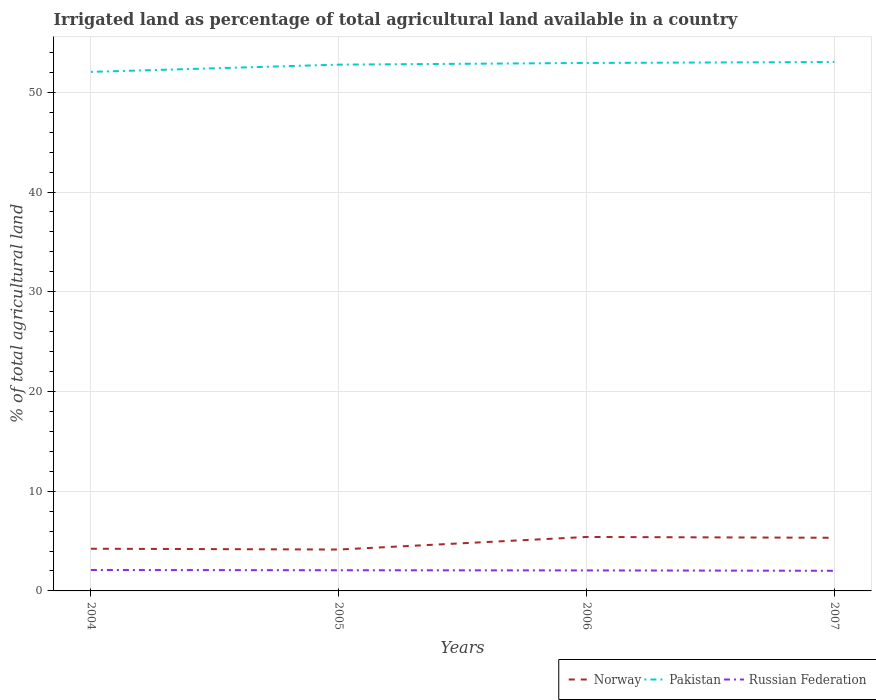How many different coloured lines are there?
Offer a terse response. 3. Is the number of lines equal to the number of legend labels?
Provide a succinct answer. Yes. Across all years, what is the maximum percentage of irrigated land in Norway?
Provide a succinct answer. 4.15. In which year was the percentage of irrigated land in Norway maximum?
Offer a terse response. 2005. What is the total percentage of irrigated land in Norway in the graph?
Give a very brief answer. 0.08. What is the difference between the highest and the second highest percentage of irrigated land in Norway?
Ensure brevity in your answer.  1.26. What is the difference between the highest and the lowest percentage of irrigated land in Pakistan?
Give a very brief answer. 3. Is the percentage of irrigated land in Pakistan strictly greater than the percentage of irrigated land in Norway over the years?
Your answer should be very brief. No. How many lines are there?
Your answer should be very brief. 3. How many years are there in the graph?
Provide a short and direct response. 4. How many legend labels are there?
Give a very brief answer. 3. What is the title of the graph?
Make the answer very short. Irrigated land as percentage of total agricultural land available in a country. What is the label or title of the X-axis?
Your answer should be compact. Years. What is the label or title of the Y-axis?
Offer a terse response. % of total agricultural land. What is the % of total agricultural land of Norway in 2004?
Provide a short and direct response. 4.23. What is the % of total agricultural land in Pakistan in 2004?
Keep it short and to the point. 52.05. What is the % of total agricultural land of Russian Federation in 2004?
Your answer should be very brief. 2.1. What is the % of total agricultural land of Norway in 2005?
Provide a short and direct response. 4.15. What is the % of total agricultural land of Pakistan in 2005?
Give a very brief answer. 52.77. What is the % of total agricultural land of Russian Federation in 2005?
Give a very brief answer. 2.07. What is the % of total agricultural land of Norway in 2006?
Provide a short and direct response. 5.41. What is the % of total agricultural land in Pakistan in 2006?
Your answer should be very brief. 52.94. What is the % of total agricultural land in Russian Federation in 2006?
Offer a terse response. 2.06. What is the % of total agricultural land of Norway in 2007?
Make the answer very short. 5.33. What is the % of total agricultural land of Pakistan in 2007?
Offer a terse response. 53.04. What is the % of total agricultural land of Russian Federation in 2007?
Keep it short and to the point. 2.02. Across all years, what is the maximum % of total agricultural land of Norway?
Make the answer very short. 5.41. Across all years, what is the maximum % of total agricultural land in Pakistan?
Give a very brief answer. 53.04. Across all years, what is the maximum % of total agricultural land in Russian Federation?
Provide a succinct answer. 2.1. Across all years, what is the minimum % of total agricultural land in Norway?
Make the answer very short. 4.15. Across all years, what is the minimum % of total agricultural land in Pakistan?
Offer a terse response. 52.05. Across all years, what is the minimum % of total agricultural land in Russian Federation?
Make the answer very short. 2.02. What is the total % of total agricultural land of Norway in the graph?
Offer a very short reply. 19.12. What is the total % of total agricultural land of Pakistan in the graph?
Keep it short and to the point. 210.8. What is the total % of total agricultural land in Russian Federation in the graph?
Give a very brief answer. 8.25. What is the difference between the % of total agricultural land of Norway in 2004 and that in 2005?
Offer a terse response. 0.08. What is the difference between the % of total agricultural land of Pakistan in 2004 and that in 2005?
Your response must be concise. -0.73. What is the difference between the % of total agricultural land in Russian Federation in 2004 and that in 2005?
Keep it short and to the point. 0.02. What is the difference between the % of total agricultural land in Norway in 2004 and that in 2006?
Ensure brevity in your answer.  -1.18. What is the difference between the % of total agricultural land of Pakistan in 2004 and that in 2006?
Offer a terse response. -0.89. What is the difference between the % of total agricultural land of Russian Federation in 2004 and that in 2006?
Provide a short and direct response. 0.04. What is the difference between the % of total agricultural land in Norway in 2004 and that in 2007?
Give a very brief answer. -1.1. What is the difference between the % of total agricultural land of Pakistan in 2004 and that in 2007?
Keep it short and to the point. -0.99. What is the difference between the % of total agricultural land in Russian Federation in 2004 and that in 2007?
Offer a very short reply. 0.08. What is the difference between the % of total agricultural land of Norway in 2005 and that in 2006?
Make the answer very short. -1.26. What is the difference between the % of total agricultural land in Pakistan in 2005 and that in 2006?
Keep it short and to the point. -0.17. What is the difference between the % of total agricultural land in Russian Federation in 2005 and that in 2006?
Give a very brief answer. 0.02. What is the difference between the % of total agricultural land of Norway in 2005 and that in 2007?
Ensure brevity in your answer.  -1.18. What is the difference between the % of total agricultural land of Pakistan in 2005 and that in 2007?
Offer a very short reply. -0.26. What is the difference between the % of total agricultural land in Russian Federation in 2005 and that in 2007?
Give a very brief answer. 0.06. What is the difference between the % of total agricultural land in Norway in 2006 and that in 2007?
Your answer should be very brief. 0.08. What is the difference between the % of total agricultural land of Pakistan in 2006 and that in 2007?
Provide a short and direct response. -0.1. What is the difference between the % of total agricultural land in Russian Federation in 2006 and that in 2007?
Keep it short and to the point. 0.04. What is the difference between the % of total agricultural land of Norway in 2004 and the % of total agricultural land of Pakistan in 2005?
Your response must be concise. -48.54. What is the difference between the % of total agricultural land in Norway in 2004 and the % of total agricultural land in Russian Federation in 2005?
Offer a terse response. 2.16. What is the difference between the % of total agricultural land in Pakistan in 2004 and the % of total agricultural land in Russian Federation in 2005?
Offer a terse response. 49.97. What is the difference between the % of total agricultural land of Norway in 2004 and the % of total agricultural land of Pakistan in 2006?
Provide a succinct answer. -48.71. What is the difference between the % of total agricultural land of Norway in 2004 and the % of total agricultural land of Russian Federation in 2006?
Offer a very short reply. 2.17. What is the difference between the % of total agricultural land of Pakistan in 2004 and the % of total agricultural land of Russian Federation in 2006?
Keep it short and to the point. 49.99. What is the difference between the % of total agricultural land of Norway in 2004 and the % of total agricultural land of Pakistan in 2007?
Offer a very short reply. -48.81. What is the difference between the % of total agricultural land of Norway in 2004 and the % of total agricultural land of Russian Federation in 2007?
Your answer should be compact. 2.21. What is the difference between the % of total agricultural land in Pakistan in 2004 and the % of total agricultural land in Russian Federation in 2007?
Offer a very short reply. 50.03. What is the difference between the % of total agricultural land in Norway in 2005 and the % of total agricultural land in Pakistan in 2006?
Provide a succinct answer. -48.79. What is the difference between the % of total agricultural land in Norway in 2005 and the % of total agricultural land in Russian Federation in 2006?
Offer a very short reply. 2.09. What is the difference between the % of total agricultural land of Pakistan in 2005 and the % of total agricultural land of Russian Federation in 2006?
Provide a short and direct response. 50.72. What is the difference between the % of total agricultural land of Norway in 2005 and the % of total agricultural land of Pakistan in 2007?
Ensure brevity in your answer.  -48.89. What is the difference between the % of total agricultural land in Norway in 2005 and the % of total agricultural land in Russian Federation in 2007?
Make the answer very short. 2.13. What is the difference between the % of total agricultural land of Pakistan in 2005 and the % of total agricultural land of Russian Federation in 2007?
Offer a very short reply. 50.75. What is the difference between the % of total agricultural land of Norway in 2006 and the % of total agricultural land of Pakistan in 2007?
Provide a succinct answer. -47.63. What is the difference between the % of total agricultural land in Norway in 2006 and the % of total agricultural land in Russian Federation in 2007?
Offer a very short reply. 3.39. What is the difference between the % of total agricultural land of Pakistan in 2006 and the % of total agricultural land of Russian Federation in 2007?
Your response must be concise. 50.92. What is the average % of total agricultural land of Norway per year?
Give a very brief answer. 4.78. What is the average % of total agricultural land in Pakistan per year?
Your response must be concise. 52.7. What is the average % of total agricultural land of Russian Federation per year?
Offer a very short reply. 2.06. In the year 2004, what is the difference between the % of total agricultural land in Norway and % of total agricultural land in Pakistan?
Provide a succinct answer. -47.82. In the year 2004, what is the difference between the % of total agricultural land in Norway and % of total agricultural land in Russian Federation?
Your answer should be very brief. 2.13. In the year 2004, what is the difference between the % of total agricultural land of Pakistan and % of total agricultural land of Russian Federation?
Keep it short and to the point. 49.95. In the year 2005, what is the difference between the % of total agricultural land in Norway and % of total agricultural land in Pakistan?
Provide a short and direct response. -48.62. In the year 2005, what is the difference between the % of total agricultural land in Norway and % of total agricultural land in Russian Federation?
Your answer should be compact. 2.08. In the year 2005, what is the difference between the % of total agricultural land of Pakistan and % of total agricultural land of Russian Federation?
Provide a succinct answer. 50.7. In the year 2006, what is the difference between the % of total agricultural land in Norway and % of total agricultural land in Pakistan?
Give a very brief answer. -47.53. In the year 2006, what is the difference between the % of total agricultural land of Norway and % of total agricultural land of Russian Federation?
Keep it short and to the point. 3.35. In the year 2006, what is the difference between the % of total agricultural land in Pakistan and % of total agricultural land in Russian Federation?
Make the answer very short. 50.88. In the year 2007, what is the difference between the % of total agricultural land in Norway and % of total agricultural land in Pakistan?
Provide a succinct answer. -47.71. In the year 2007, what is the difference between the % of total agricultural land in Norway and % of total agricultural land in Russian Federation?
Keep it short and to the point. 3.31. In the year 2007, what is the difference between the % of total agricultural land in Pakistan and % of total agricultural land in Russian Federation?
Your response must be concise. 51.02. What is the ratio of the % of total agricultural land of Norway in 2004 to that in 2005?
Give a very brief answer. 1.02. What is the ratio of the % of total agricultural land of Pakistan in 2004 to that in 2005?
Your answer should be very brief. 0.99. What is the ratio of the % of total agricultural land in Russian Federation in 2004 to that in 2005?
Ensure brevity in your answer.  1.01. What is the ratio of the % of total agricultural land of Norway in 2004 to that in 2006?
Offer a very short reply. 0.78. What is the ratio of the % of total agricultural land in Pakistan in 2004 to that in 2006?
Provide a short and direct response. 0.98. What is the ratio of the % of total agricultural land in Russian Federation in 2004 to that in 2006?
Offer a terse response. 1.02. What is the ratio of the % of total agricultural land in Norway in 2004 to that in 2007?
Offer a very short reply. 0.79. What is the ratio of the % of total agricultural land in Pakistan in 2004 to that in 2007?
Give a very brief answer. 0.98. What is the ratio of the % of total agricultural land of Russian Federation in 2004 to that in 2007?
Your answer should be very brief. 1.04. What is the ratio of the % of total agricultural land in Norway in 2005 to that in 2006?
Provide a short and direct response. 0.77. What is the ratio of the % of total agricultural land of Russian Federation in 2005 to that in 2006?
Give a very brief answer. 1.01. What is the ratio of the % of total agricultural land of Norway in 2005 to that in 2007?
Provide a succinct answer. 0.78. What is the ratio of the % of total agricultural land of Russian Federation in 2005 to that in 2007?
Your response must be concise. 1.03. What is the ratio of the % of total agricultural land of Norway in 2006 to that in 2007?
Your answer should be very brief. 1.02. What is the ratio of the % of total agricultural land of Russian Federation in 2006 to that in 2007?
Provide a succinct answer. 1.02. What is the difference between the highest and the second highest % of total agricultural land of Norway?
Keep it short and to the point. 0.08. What is the difference between the highest and the second highest % of total agricultural land in Pakistan?
Provide a short and direct response. 0.1. What is the difference between the highest and the second highest % of total agricultural land of Russian Federation?
Make the answer very short. 0.02. What is the difference between the highest and the lowest % of total agricultural land in Norway?
Give a very brief answer. 1.26. What is the difference between the highest and the lowest % of total agricultural land of Pakistan?
Your response must be concise. 0.99. What is the difference between the highest and the lowest % of total agricultural land in Russian Federation?
Provide a short and direct response. 0.08. 